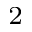Convert formula to latex. <formula><loc_0><loc_0><loc_500><loc_500>^ { 2 }</formula> 